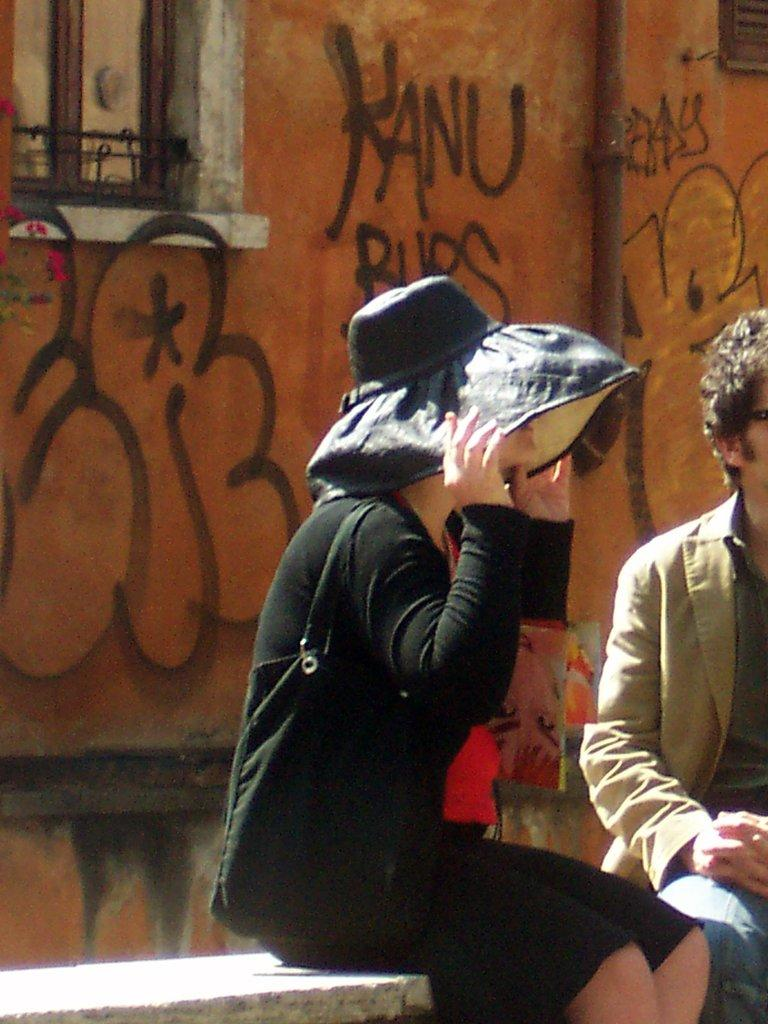<image>
Render a clear and concise summary of the photo. A woman wearing a black hat sits on a bench behind a will with Kanu written on it. 